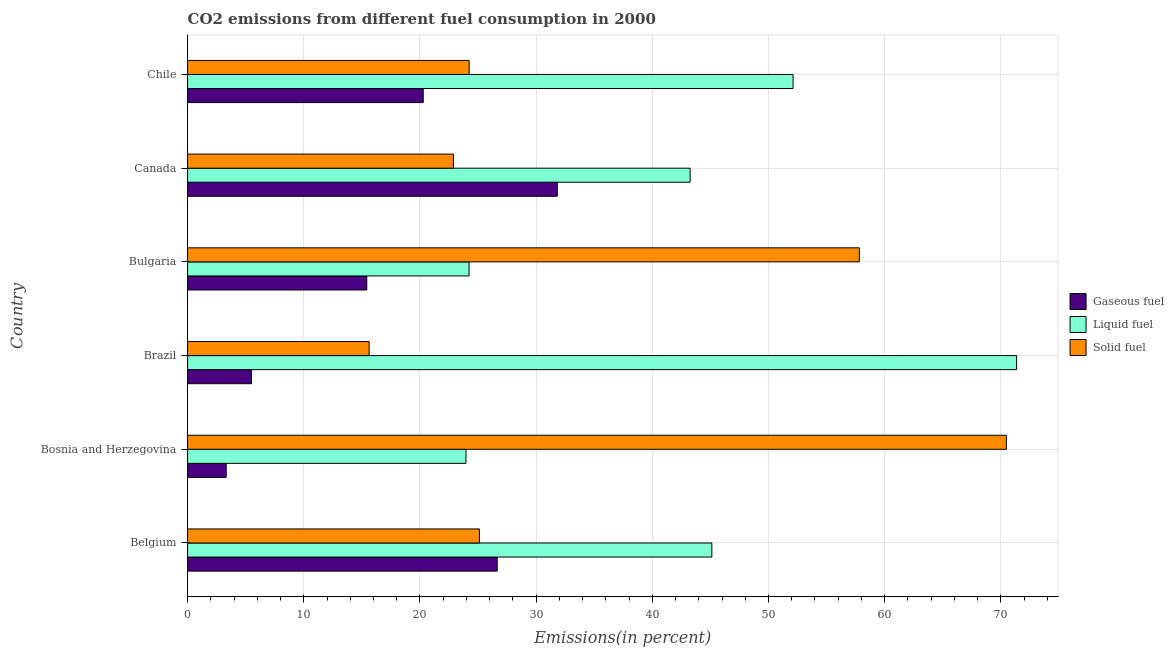How many groups of bars are there?
Your answer should be very brief. 6. Are the number of bars per tick equal to the number of legend labels?
Offer a very short reply. Yes. Are the number of bars on each tick of the Y-axis equal?
Provide a short and direct response. Yes. How many bars are there on the 5th tick from the bottom?
Offer a very short reply. 3. What is the label of the 3rd group of bars from the top?
Give a very brief answer. Bulgaria. In how many cases, is the number of bars for a given country not equal to the number of legend labels?
Your response must be concise. 0. What is the percentage of gaseous fuel emission in Brazil?
Ensure brevity in your answer.  5.5. Across all countries, what is the maximum percentage of solid fuel emission?
Offer a terse response. 70.48. Across all countries, what is the minimum percentage of liquid fuel emission?
Your response must be concise. 23.96. In which country was the percentage of gaseous fuel emission minimum?
Keep it short and to the point. Bosnia and Herzegovina. What is the total percentage of liquid fuel emission in the graph?
Ensure brevity in your answer.  260.05. What is the difference between the percentage of gaseous fuel emission in Belgium and that in Canada?
Offer a terse response. -5.17. What is the difference between the percentage of liquid fuel emission in Canada and the percentage of gaseous fuel emission in Chile?
Make the answer very short. 22.97. What is the average percentage of gaseous fuel emission per country?
Offer a very short reply. 17.17. What is the difference between the percentage of gaseous fuel emission and percentage of solid fuel emission in Bulgaria?
Your answer should be very brief. -42.4. What is the ratio of the percentage of solid fuel emission in Belgium to that in Canada?
Offer a terse response. 1.1. Is the difference between the percentage of liquid fuel emission in Brazil and Chile greater than the difference between the percentage of gaseous fuel emission in Brazil and Chile?
Ensure brevity in your answer.  Yes. What is the difference between the highest and the second highest percentage of solid fuel emission?
Offer a terse response. 12.66. What is the difference between the highest and the lowest percentage of liquid fuel emission?
Keep it short and to the point. 47.4. In how many countries, is the percentage of liquid fuel emission greater than the average percentage of liquid fuel emission taken over all countries?
Give a very brief answer. 3. What does the 1st bar from the top in Belgium represents?
Give a very brief answer. Solid fuel. What does the 3rd bar from the bottom in Brazil represents?
Your response must be concise. Solid fuel. What is the difference between two consecutive major ticks on the X-axis?
Your response must be concise. 10. Are the values on the major ticks of X-axis written in scientific E-notation?
Give a very brief answer. No. Does the graph contain any zero values?
Give a very brief answer. No. How many legend labels are there?
Offer a terse response. 3. How are the legend labels stacked?
Offer a terse response. Vertical. What is the title of the graph?
Offer a very short reply. CO2 emissions from different fuel consumption in 2000. What is the label or title of the X-axis?
Offer a very short reply. Emissions(in percent). What is the Emissions(in percent) of Gaseous fuel in Belgium?
Keep it short and to the point. 26.65. What is the Emissions(in percent) of Liquid fuel in Belgium?
Ensure brevity in your answer.  45.13. What is the Emissions(in percent) in Solid fuel in Belgium?
Your answer should be very brief. 25.12. What is the Emissions(in percent) of Gaseous fuel in Bosnia and Herzegovina?
Offer a very short reply. 3.32. What is the Emissions(in percent) of Liquid fuel in Bosnia and Herzegovina?
Keep it short and to the point. 23.96. What is the Emissions(in percent) in Solid fuel in Bosnia and Herzegovina?
Give a very brief answer. 70.48. What is the Emissions(in percent) in Gaseous fuel in Brazil?
Make the answer very short. 5.5. What is the Emissions(in percent) in Liquid fuel in Brazil?
Provide a short and direct response. 71.36. What is the Emissions(in percent) in Solid fuel in Brazil?
Provide a short and direct response. 15.63. What is the Emissions(in percent) in Gaseous fuel in Bulgaria?
Offer a terse response. 15.42. What is the Emissions(in percent) in Liquid fuel in Bulgaria?
Your answer should be compact. 24.23. What is the Emissions(in percent) in Solid fuel in Bulgaria?
Your answer should be compact. 57.82. What is the Emissions(in percent) in Gaseous fuel in Canada?
Make the answer very short. 31.82. What is the Emissions(in percent) in Liquid fuel in Canada?
Provide a succinct answer. 43.26. What is the Emissions(in percent) in Solid fuel in Canada?
Offer a very short reply. 22.88. What is the Emissions(in percent) in Gaseous fuel in Chile?
Give a very brief answer. 20.28. What is the Emissions(in percent) of Liquid fuel in Chile?
Provide a short and direct response. 52.12. What is the Emissions(in percent) of Solid fuel in Chile?
Offer a very short reply. 24.23. Across all countries, what is the maximum Emissions(in percent) in Gaseous fuel?
Your response must be concise. 31.82. Across all countries, what is the maximum Emissions(in percent) in Liquid fuel?
Keep it short and to the point. 71.36. Across all countries, what is the maximum Emissions(in percent) of Solid fuel?
Give a very brief answer. 70.48. Across all countries, what is the minimum Emissions(in percent) in Gaseous fuel?
Your answer should be very brief. 3.32. Across all countries, what is the minimum Emissions(in percent) of Liquid fuel?
Your answer should be compact. 23.96. Across all countries, what is the minimum Emissions(in percent) of Solid fuel?
Make the answer very short. 15.63. What is the total Emissions(in percent) of Gaseous fuel in the graph?
Your answer should be compact. 103. What is the total Emissions(in percent) of Liquid fuel in the graph?
Your response must be concise. 260.05. What is the total Emissions(in percent) in Solid fuel in the graph?
Ensure brevity in your answer.  216.16. What is the difference between the Emissions(in percent) in Gaseous fuel in Belgium and that in Bosnia and Herzegovina?
Your answer should be compact. 23.33. What is the difference between the Emissions(in percent) of Liquid fuel in Belgium and that in Bosnia and Herzegovina?
Offer a very short reply. 21.16. What is the difference between the Emissions(in percent) of Solid fuel in Belgium and that in Bosnia and Herzegovina?
Keep it short and to the point. -45.36. What is the difference between the Emissions(in percent) of Gaseous fuel in Belgium and that in Brazil?
Keep it short and to the point. 21.15. What is the difference between the Emissions(in percent) of Liquid fuel in Belgium and that in Brazil?
Your response must be concise. -26.23. What is the difference between the Emissions(in percent) in Solid fuel in Belgium and that in Brazil?
Offer a very short reply. 9.5. What is the difference between the Emissions(in percent) of Gaseous fuel in Belgium and that in Bulgaria?
Make the answer very short. 11.23. What is the difference between the Emissions(in percent) of Liquid fuel in Belgium and that in Bulgaria?
Ensure brevity in your answer.  20.9. What is the difference between the Emissions(in percent) in Solid fuel in Belgium and that in Bulgaria?
Provide a succinct answer. -32.7. What is the difference between the Emissions(in percent) in Gaseous fuel in Belgium and that in Canada?
Offer a terse response. -5.17. What is the difference between the Emissions(in percent) of Liquid fuel in Belgium and that in Canada?
Offer a terse response. 1.87. What is the difference between the Emissions(in percent) in Solid fuel in Belgium and that in Canada?
Your answer should be compact. 2.24. What is the difference between the Emissions(in percent) of Gaseous fuel in Belgium and that in Chile?
Ensure brevity in your answer.  6.37. What is the difference between the Emissions(in percent) of Liquid fuel in Belgium and that in Chile?
Keep it short and to the point. -6.99. What is the difference between the Emissions(in percent) in Solid fuel in Belgium and that in Chile?
Make the answer very short. 0.89. What is the difference between the Emissions(in percent) of Gaseous fuel in Bosnia and Herzegovina and that in Brazil?
Your answer should be very brief. -2.17. What is the difference between the Emissions(in percent) of Liquid fuel in Bosnia and Herzegovina and that in Brazil?
Your answer should be very brief. -47.4. What is the difference between the Emissions(in percent) in Solid fuel in Bosnia and Herzegovina and that in Brazil?
Make the answer very short. 54.85. What is the difference between the Emissions(in percent) in Gaseous fuel in Bosnia and Herzegovina and that in Bulgaria?
Give a very brief answer. -12.1. What is the difference between the Emissions(in percent) of Liquid fuel in Bosnia and Herzegovina and that in Bulgaria?
Provide a short and direct response. -0.26. What is the difference between the Emissions(in percent) in Solid fuel in Bosnia and Herzegovina and that in Bulgaria?
Offer a very short reply. 12.66. What is the difference between the Emissions(in percent) in Gaseous fuel in Bosnia and Herzegovina and that in Canada?
Your answer should be compact. -28.5. What is the difference between the Emissions(in percent) in Liquid fuel in Bosnia and Herzegovina and that in Canada?
Provide a short and direct response. -19.29. What is the difference between the Emissions(in percent) of Solid fuel in Bosnia and Herzegovina and that in Canada?
Your response must be concise. 47.6. What is the difference between the Emissions(in percent) in Gaseous fuel in Bosnia and Herzegovina and that in Chile?
Provide a short and direct response. -16.96. What is the difference between the Emissions(in percent) in Liquid fuel in Bosnia and Herzegovina and that in Chile?
Keep it short and to the point. -28.15. What is the difference between the Emissions(in percent) of Solid fuel in Bosnia and Herzegovina and that in Chile?
Offer a terse response. 46.24. What is the difference between the Emissions(in percent) in Gaseous fuel in Brazil and that in Bulgaria?
Provide a short and direct response. -9.93. What is the difference between the Emissions(in percent) of Liquid fuel in Brazil and that in Bulgaria?
Your answer should be compact. 47.13. What is the difference between the Emissions(in percent) in Solid fuel in Brazil and that in Bulgaria?
Keep it short and to the point. -42.2. What is the difference between the Emissions(in percent) in Gaseous fuel in Brazil and that in Canada?
Your response must be concise. -26.33. What is the difference between the Emissions(in percent) of Liquid fuel in Brazil and that in Canada?
Provide a succinct answer. 28.1. What is the difference between the Emissions(in percent) in Solid fuel in Brazil and that in Canada?
Provide a short and direct response. -7.25. What is the difference between the Emissions(in percent) in Gaseous fuel in Brazil and that in Chile?
Give a very brief answer. -14.79. What is the difference between the Emissions(in percent) in Liquid fuel in Brazil and that in Chile?
Your response must be concise. 19.24. What is the difference between the Emissions(in percent) in Solid fuel in Brazil and that in Chile?
Your answer should be compact. -8.61. What is the difference between the Emissions(in percent) in Gaseous fuel in Bulgaria and that in Canada?
Keep it short and to the point. -16.4. What is the difference between the Emissions(in percent) in Liquid fuel in Bulgaria and that in Canada?
Your answer should be compact. -19.03. What is the difference between the Emissions(in percent) in Solid fuel in Bulgaria and that in Canada?
Give a very brief answer. 34.94. What is the difference between the Emissions(in percent) in Gaseous fuel in Bulgaria and that in Chile?
Offer a terse response. -4.86. What is the difference between the Emissions(in percent) of Liquid fuel in Bulgaria and that in Chile?
Give a very brief answer. -27.89. What is the difference between the Emissions(in percent) in Solid fuel in Bulgaria and that in Chile?
Offer a terse response. 33.59. What is the difference between the Emissions(in percent) of Gaseous fuel in Canada and that in Chile?
Give a very brief answer. 11.54. What is the difference between the Emissions(in percent) of Liquid fuel in Canada and that in Chile?
Offer a very short reply. -8.86. What is the difference between the Emissions(in percent) in Solid fuel in Canada and that in Chile?
Offer a very short reply. -1.35. What is the difference between the Emissions(in percent) in Gaseous fuel in Belgium and the Emissions(in percent) in Liquid fuel in Bosnia and Herzegovina?
Offer a very short reply. 2.69. What is the difference between the Emissions(in percent) of Gaseous fuel in Belgium and the Emissions(in percent) of Solid fuel in Bosnia and Herzegovina?
Your answer should be very brief. -43.83. What is the difference between the Emissions(in percent) in Liquid fuel in Belgium and the Emissions(in percent) in Solid fuel in Bosnia and Herzegovina?
Ensure brevity in your answer.  -25.35. What is the difference between the Emissions(in percent) in Gaseous fuel in Belgium and the Emissions(in percent) in Liquid fuel in Brazil?
Give a very brief answer. -44.71. What is the difference between the Emissions(in percent) in Gaseous fuel in Belgium and the Emissions(in percent) in Solid fuel in Brazil?
Your answer should be compact. 11.02. What is the difference between the Emissions(in percent) in Liquid fuel in Belgium and the Emissions(in percent) in Solid fuel in Brazil?
Offer a terse response. 29.5. What is the difference between the Emissions(in percent) of Gaseous fuel in Belgium and the Emissions(in percent) of Liquid fuel in Bulgaria?
Provide a short and direct response. 2.42. What is the difference between the Emissions(in percent) of Gaseous fuel in Belgium and the Emissions(in percent) of Solid fuel in Bulgaria?
Provide a short and direct response. -31.17. What is the difference between the Emissions(in percent) in Liquid fuel in Belgium and the Emissions(in percent) in Solid fuel in Bulgaria?
Ensure brevity in your answer.  -12.7. What is the difference between the Emissions(in percent) of Gaseous fuel in Belgium and the Emissions(in percent) of Liquid fuel in Canada?
Give a very brief answer. -16.61. What is the difference between the Emissions(in percent) in Gaseous fuel in Belgium and the Emissions(in percent) in Solid fuel in Canada?
Offer a terse response. 3.77. What is the difference between the Emissions(in percent) of Liquid fuel in Belgium and the Emissions(in percent) of Solid fuel in Canada?
Provide a succinct answer. 22.25. What is the difference between the Emissions(in percent) of Gaseous fuel in Belgium and the Emissions(in percent) of Liquid fuel in Chile?
Keep it short and to the point. -25.47. What is the difference between the Emissions(in percent) of Gaseous fuel in Belgium and the Emissions(in percent) of Solid fuel in Chile?
Offer a very short reply. 2.42. What is the difference between the Emissions(in percent) in Liquid fuel in Belgium and the Emissions(in percent) in Solid fuel in Chile?
Make the answer very short. 20.89. What is the difference between the Emissions(in percent) of Gaseous fuel in Bosnia and Herzegovina and the Emissions(in percent) of Liquid fuel in Brazil?
Your answer should be very brief. -68.03. What is the difference between the Emissions(in percent) in Gaseous fuel in Bosnia and Herzegovina and the Emissions(in percent) in Solid fuel in Brazil?
Provide a short and direct response. -12.3. What is the difference between the Emissions(in percent) in Liquid fuel in Bosnia and Herzegovina and the Emissions(in percent) in Solid fuel in Brazil?
Make the answer very short. 8.34. What is the difference between the Emissions(in percent) of Gaseous fuel in Bosnia and Herzegovina and the Emissions(in percent) of Liquid fuel in Bulgaria?
Offer a terse response. -20.9. What is the difference between the Emissions(in percent) in Gaseous fuel in Bosnia and Herzegovina and the Emissions(in percent) in Solid fuel in Bulgaria?
Offer a terse response. -54.5. What is the difference between the Emissions(in percent) of Liquid fuel in Bosnia and Herzegovina and the Emissions(in percent) of Solid fuel in Bulgaria?
Make the answer very short. -33.86. What is the difference between the Emissions(in percent) in Gaseous fuel in Bosnia and Herzegovina and the Emissions(in percent) in Liquid fuel in Canada?
Provide a succinct answer. -39.93. What is the difference between the Emissions(in percent) in Gaseous fuel in Bosnia and Herzegovina and the Emissions(in percent) in Solid fuel in Canada?
Your response must be concise. -19.56. What is the difference between the Emissions(in percent) of Liquid fuel in Bosnia and Herzegovina and the Emissions(in percent) of Solid fuel in Canada?
Ensure brevity in your answer.  1.08. What is the difference between the Emissions(in percent) of Gaseous fuel in Bosnia and Herzegovina and the Emissions(in percent) of Liquid fuel in Chile?
Your answer should be compact. -48.79. What is the difference between the Emissions(in percent) of Gaseous fuel in Bosnia and Herzegovina and the Emissions(in percent) of Solid fuel in Chile?
Provide a succinct answer. -20.91. What is the difference between the Emissions(in percent) in Liquid fuel in Bosnia and Herzegovina and the Emissions(in percent) in Solid fuel in Chile?
Provide a succinct answer. -0.27. What is the difference between the Emissions(in percent) of Gaseous fuel in Brazil and the Emissions(in percent) of Liquid fuel in Bulgaria?
Provide a short and direct response. -18.73. What is the difference between the Emissions(in percent) in Gaseous fuel in Brazil and the Emissions(in percent) in Solid fuel in Bulgaria?
Provide a succinct answer. -52.33. What is the difference between the Emissions(in percent) of Liquid fuel in Brazil and the Emissions(in percent) of Solid fuel in Bulgaria?
Provide a succinct answer. 13.54. What is the difference between the Emissions(in percent) in Gaseous fuel in Brazil and the Emissions(in percent) in Liquid fuel in Canada?
Offer a very short reply. -37.76. What is the difference between the Emissions(in percent) in Gaseous fuel in Brazil and the Emissions(in percent) in Solid fuel in Canada?
Give a very brief answer. -17.39. What is the difference between the Emissions(in percent) of Liquid fuel in Brazil and the Emissions(in percent) of Solid fuel in Canada?
Give a very brief answer. 48.48. What is the difference between the Emissions(in percent) in Gaseous fuel in Brazil and the Emissions(in percent) in Liquid fuel in Chile?
Ensure brevity in your answer.  -46.62. What is the difference between the Emissions(in percent) of Gaseous fuel in Brazil and the Emissions(in percent) of Solid fuel in Chile?
Keep it short and to the point. -18.74. What is the difference between the Emissions(in percent) in Liquid fuel in Brazil and the Emissions(in percent) in Solid fuel in Chile?
Make the answer very short. 47.12. What is the difference between the Emissions(in percent) of Gaseous fuel in Bulgaria and the Emissions(in percent) of Liquid fuel in Canada?
Offer a terse response. -27.83. What is the difference between the Emissions(in percent) in Gaseous fuel in Bulgaria and the Emissions(in percent) in Solid fuel in Canada?
Provide a short and direct response. -7.46. What is the difference between the Emissions(in percent) of Liquid fuel in Bulgaria and the Emissions(in percent) of Solid fuel in Canada?
Offer a very short reply. 1.35. What is the difference between the Emissions(in percent) of Gaseous fuel in Bulgaria and the Emissions(in percent) of Liquid fuel in Chile?
Make the answer very short. -36.69. What is the difference between the Emissions(in percent) of Gaseous fuel in Bulgaria and the Emissions(in percent) of Solid fuel in Chile?
Offer a very short reply. -8.81. What is the difference between the Emissions(in percent) in Liquid fuel in Bulgaria and the Emissions(in percent) in Solid fuel in Chile?
Your answer should be very brief. -0.01. What is the difference between the Emissions(in percent) in Gaseous fuel in Canada and the Emissions(in percent) in Liquid fuel in Chile?
Your answer should be compact. -20.3. What is the difference between the Emissions(in percent) in Gaseous fuel in Canada and the Emissions(in percent) in Solid fuel in Chile?
Provide a short and direct response. 7.59. What is the difference between the Emissions(in percent) of Liquid fuel in Canada and the Emissions(in percent) of Solid fuel in Chile?
Provide a short and direct response. 19.02. What is the average Emissions(in percent) of Gaseous fuel per country?
Offer a terse response. 17.17. What is the average Emissions(in percent) of Liquid fuel per country?
Keep it short and to the point. 43.34. What is the average Emissions(in percent) of Solid fuel per country?
Keep it short and to the point. 36.03. What is the difference between the Emissions(in percent) of Gaseous fuel and Emissions(in percent) of Liquid fuel in Belgium?
Offer a very short reply. -18.48. What is the difference between the Emissions(in percent) of Gaseous fuel and Emissions(in percent) of Solid fuel in Belgium?
Offer a very short reply. 1.53. What is the difference between the Emissions(in percent) in Liquid fuel and Emissions(in percent) in Solid fuel in Belgium?
Offer a very short reply. 20.01. What is the difference between the Emissions(in percent) in Gaseous fuel and Emissions(in percent) in Liquid fuel in Bosnia and Herzegovina?
Your answer should be very brief. -20.64. What is the difference between the Emissions(in percent) of Gaseous fuel and Emissions(in percent) of Solid fuel in Bosnia and Herzegovina?
Offer a very short reply. -67.15. What is the difference between the Emissions(in percent) of Liquid fuel and Emissions(in percent) of Solid fuel in Bosnia and Herzegovina?
Ensure brevity in your answer.  -46.52. What is the difference between the Emissions(in percent) in Gaseous fuel and Emissions(in percent) in Liquid fuel in Brazil?
Keep it short and to the point. -65.86. What is the difference between the Emissions(in percent) of Gaseous fuel and Emissions(in percent) of Solid fuel in Brazil?
Your answer should be very brief. -10.13. What is the difference between the Emissions(in percent) in Liquid fuel and Emissions(in percent) in Solid fuel in Brazil?
Offer a terse response. 55.73. What is the difference between the Emissions(in percent) of Gaseous fuel and Emissions(in percent) of Liquid fuel in Bulgaria?
Provide a succinct answer. -8.8. What is the difference between the Emissions(in percent) in Gaseous fuel and Emissions(in percent) in Solid fuel in Bulgaria?
Offer a terse response. -42.4. What is the difference between the Emissions(in percent) of Liquid fuel and Emissions(in percent) of Solid fuel in Bulgaria?
Your answer should be very brief. -33.59. What is the difference between the Emissions(in percent) of Gaseous fuel and Emissions(in percent) of Liquid fuel in Canada?
Give a very brief answer. -11.44. What is the difference between the Emissions(in percent) of Gaseous fuel and Emissions(in percent) of Solid fuel in Canada?
Keep it short and to the point. 8.94. What is the difference between the Emissions(in percent) in Liquid fuel and Emissions(in percent) in Solid fuel in Canada?
Ensure brevity in your answer.  20.38. What is the difference between the Emissions(in percent) in Gaseous fuel and Emissions(in percent) in Liquid fuel in Chile?
Ensure brevity in your answer.  -31.83. What is the difference between the Emissions(in percent) in Gaseous fuel and Emissions(in percent) in Solid fuel in Chile?
Provide a short and direct response. -3.95. What is the difference between the Emissions(in percent) of Liquid fuel and Emissions(in percent) of Solid fuel in Chile?
Your answer should be compact. 27.88. What is the ratio of the Emissions(in percent) in Gaseous fuel in Belgium to that in Bosnia and Herzegovina?
Offer a very short reply. 8.02. What is the ratio of the Emissions(in percent) of Liquid fuel in Belgium to that in Bosnia and Herzegovina?
Your answer should be compact. 1.88. What is the ratio of the Emissions(in percent) of Solid fuel in Belgium to that in Bosnia and Herzegovina?
Your answer should be compact. 0.36. What is the ratio of the Emissions(in percent) of Gaseous fuel in Belgium to that in Brazil?
Keep it short and to the point. 4.85. What is the ratio of the Emissions(in percent) of Liquid fuel in Belgium to that in Brazil?
Offer a very short reply. 0.63. What is the ratio of the Emissions(in percent) in Solid fuel in Belgium to that in Brazil?
Your response must be concise. 1.61. What is the ratio of the Emissions(in percent) of Gaseous fuel in Belgium to that in Bulgaria?
Offer a terse response. 1.73. What is the ratio of the Emissions(in percent) in Liquid fuel in Belgium to that in Bulgaria?
Offer a very short reply. 1.86. What is the ratio of the Emissions(in percent) of Solid fuel in Belgium to that in Bulgaria?
Ensure brevity in your answer.  0.43. What is the ratio of the Emissions(in percent) of Gaseous fuel in Belgium to that in Canada?
Provide a succinct answer. 0.84. What is the ratio of the Emissions(in percent) of Liquid fuel in Belgium to that in Canada?
Provide a short and direct response. 1.04. What is the ratio of the Emissions(in percent) of Solid fuel in Belgium to that in Canada?
Provide a short and direct response. 1.1. What is the ratio of the Emissions(in percent) in Gaseous fuel in Belgium to that in Chile?
Provide a short and direct response. 1.31. What is the ratio of the Emissions(in percent) of Liquid fuel in Belgium to that in Chile?
Keep it short and to the point. 0.87. What is the ratio of the Emissions(in percent) of Solid fuel in Belgium to that in Chile?
Offer a very short reply. 1.04. What is the ratio of the Emissions(in percent) in Gaseous fuel in Bosnia and Herzegovina to that in Brazil?
Your response must be concise. 0.6. What is the ratio of the Emissions(in percent) of Liquid fuel in Bosnia and Herzegovina to that in Brazil?
Provide a succinct answer. 0.34. What is the ratio of the Emissions(in percent) of Solid fuel in Bosnia and Herzegovina to that in Brazil?
Give a very brief answer. 4.51. What is the ratio of the Emissions(in percent) in Gaseous fuel in Bosnia and Herzegovina to that in Bulgaria?
Provide a succinct answer. 0.22. What is the ratio of the Emissions(in percent) in Liquid fuel in Bosnia and Herzegovina to that in Bulgaria?
Ensure brevity in your answer.  0.99. What is the ratio of the Emissions(in percent) of Solid fuel in Bosnia and Herzegovina to that in Bulgaria?
Offer a terse response. 1.22. What is the ratio of the Emissions(in percent) in Gaseous fuel in Bosnia and Herzegovina to that in Canada?
Offer a terse response. 0.1. What is the ratio of the Emissions(in percent) in Liquid fuel in Bosnia and Herzegovina to that in Canada?
Your answer should be very brief. 0.55. What is the ratio of the Emissions(in percent) of Solid fuel in Bosnia and Herzegovina to that in Canada?
Offer a terse response. 3.08. What is the ratio of the Emissions(in percent) of Gaseous fuel in Bosnia and Herzegovina to that in Chile?
Your answer should be very brief. 0.16. What is the ratio of the Emissions(in percent) of Liquid fuel in Bosnia and Herzegovina to that in Chile?
Offer a very short reply. 0.46. What is the ratio of the Emissions(in percent) in Solid fuel in Bosnia and Herzegovina to that in Chile?
Offer a terse response. 2.91. What is the ratio of the Emissions(in percent) in Gaseous fuel in Brazil to that in Bulgaria?
Provide a short and direct response. 0.36. What is the ratio of the Emissions(in percent) of Liquid fuel in Brazil to that in Bulgaria?
Your answer should be very brief. 2.95. What is the ratio of the Emissions(in percent) in Solid fuel in Brazil to that in Bulgaria?
Make the answer very short. 0.27. What is the ratio of the Emissions(in percent) in Gaseous fuel in Brazil to that in Canada?
Make the answer very short. 0.17. What is the ratio of the Emissions(in percent) of Liquid fuel in Brazil to that in Canada?
Keep it short and to the point. 1.65. What is the ratio of the Emissions(in percent) in Solid fuel in Brazil to that in Canada?
Offer a terse response. 0.68. What is the ratio of the Emissions(in percent) of Gaseous fuel in Brazil to that in Chile?
Give a very brief answer. 0.27. What is the ratio of the Emissions(in percent) of Liquid fuel in Brazil to that in Chile?
Offer a very short reply. 1.37. What is the ratio of the Emissions(in percent) in Solid fuel in Brazil to that in Chile?
Your response must be concise. 0.64. What is the ratio of the Emissions(in percent) in Gaseous fuel in Bulgaria to that in Canada?
Provide a short and direct response. 0.48. What is the ratio of the Emissions(in percent) of Liquid fuel in Bulgaria to that in Canada?
Offer a terse response. 0.56. What is the ratio of the Emissions(in percent) of Solid fuel in Bulgaria to that in Canada?
Provide a succinct answer. 2.53. What is the ratio of the Emissions(in percent) of Gaseous fuel in Bulgaria to that in Chile?
Make the answer very short. 0.76. What is the ratio of the Emissions(in percent) of Liquid fuel in Bulgaria to that in Chile?
Provide a short and direct response. 0.46. What is the ratio of the Emissions(in percent) in Solid fuel in Bulgaria to that in Chile?
Your answer should be compact. 2.39. What is the ratio of the Emissions(in percent) of Gaseous fuel in Canada to that in Chile?
Your answer should be very brief. 1.57. What is the ratio of the Emissions(in percent) of Liquid fuel in Canada to that in Chile?
Give a very brief answer. 0.83. What is the ratio of the Emissions(in percent) of Solid fuel in Canada to that in Chile?
Ensure brevity in your answer.  0.94. What is the difference between the highest and the second highest Emissions(in percent) in Gaseous fuel?
Provide a succinct answer. 5.17. What is the difference between the highest and the second highest Emissions(in percent) of Liquid fuel?
Your answer should be very brief. 19.24. What is the difference between the highest and the second highest Emissions(in percent) of Solid fuel?
Your response must be concise. 12.66. What is the difference between the highest and the lowest Emissions(in percent) in Gaseous fuel?
Give a very brief answer. 28.5. What is the difference between the highest and the lowest Emissions(in percent) of Liquid fuel?
Your answer should be compact. 47.4. What is the difference between the highest and the lowest Emissions(in percent) in Solid fuel?
Your response must be concise. 54.85. 